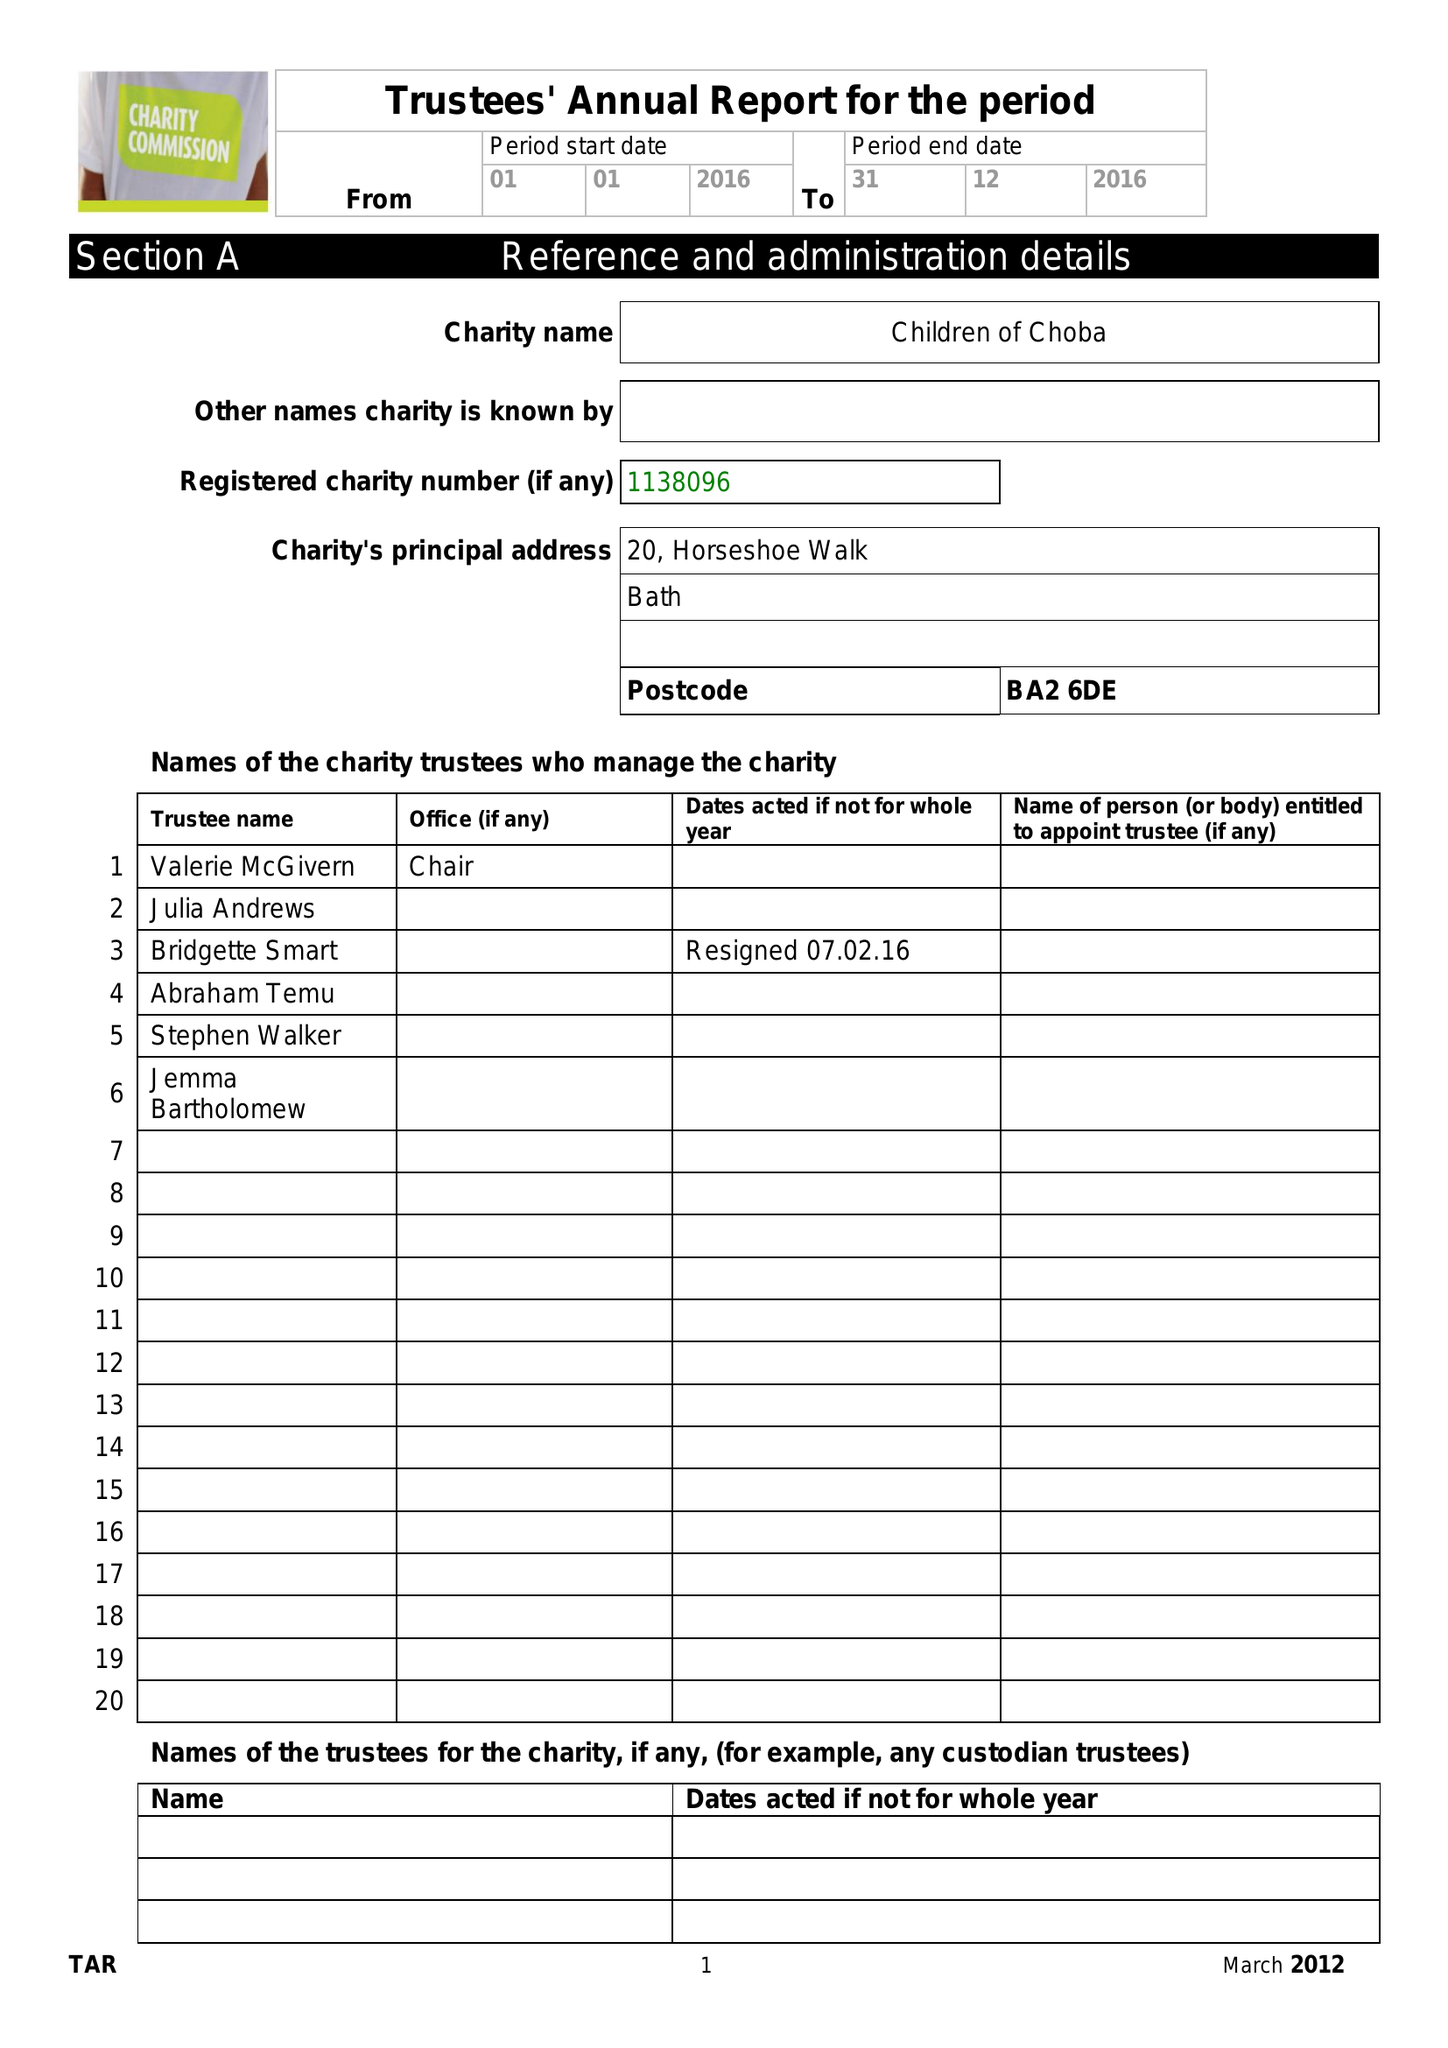What is the value for the address__post_town?
Answer the question using a single word or phrase. BATH 